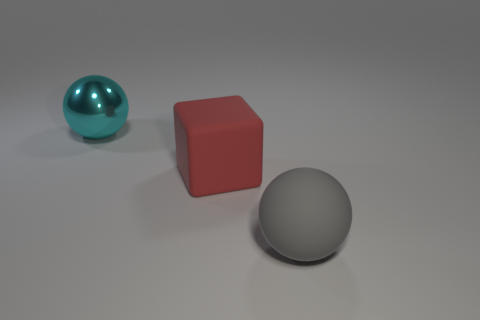What is the size of the ball on the right side of the sphere to the left of the gray ball?
Keep it short and to the point. Large. What shape is the big cyan object?
Ensure brevity in your answer.  Sphere. What is the thing right of the large red cube made of?
Provide a succinct answer. Rubber. What is the color of the object that is on the right side of the big red matte thing behind the large matte thing in front of the large matte cube?
Make the answer very short. Gray. There is a block that is the same size as the cyan metallic ball; what color is it?
Give a very brief answer. Red. How many metal objects are either green objects or big red cubes?
Provide a short and direct response. 0. There is a big ball that is made of the same material as the cube; what is its color?
Your answer should be very brief. Gray. There is a ball left of the large sphere to the right of the large metal ball; what is it made of?
Provide a succinct answer. Metal. What number of things are large rubber things on the right side of the red cube or rubber objects on the right side of the red matte object?
Provide a succinct answer. 1. Are there the same number of metallic spheres that are to the left of the big cyan object and small blue shiny cylinders?
Provide a short and direct response. Yes. 